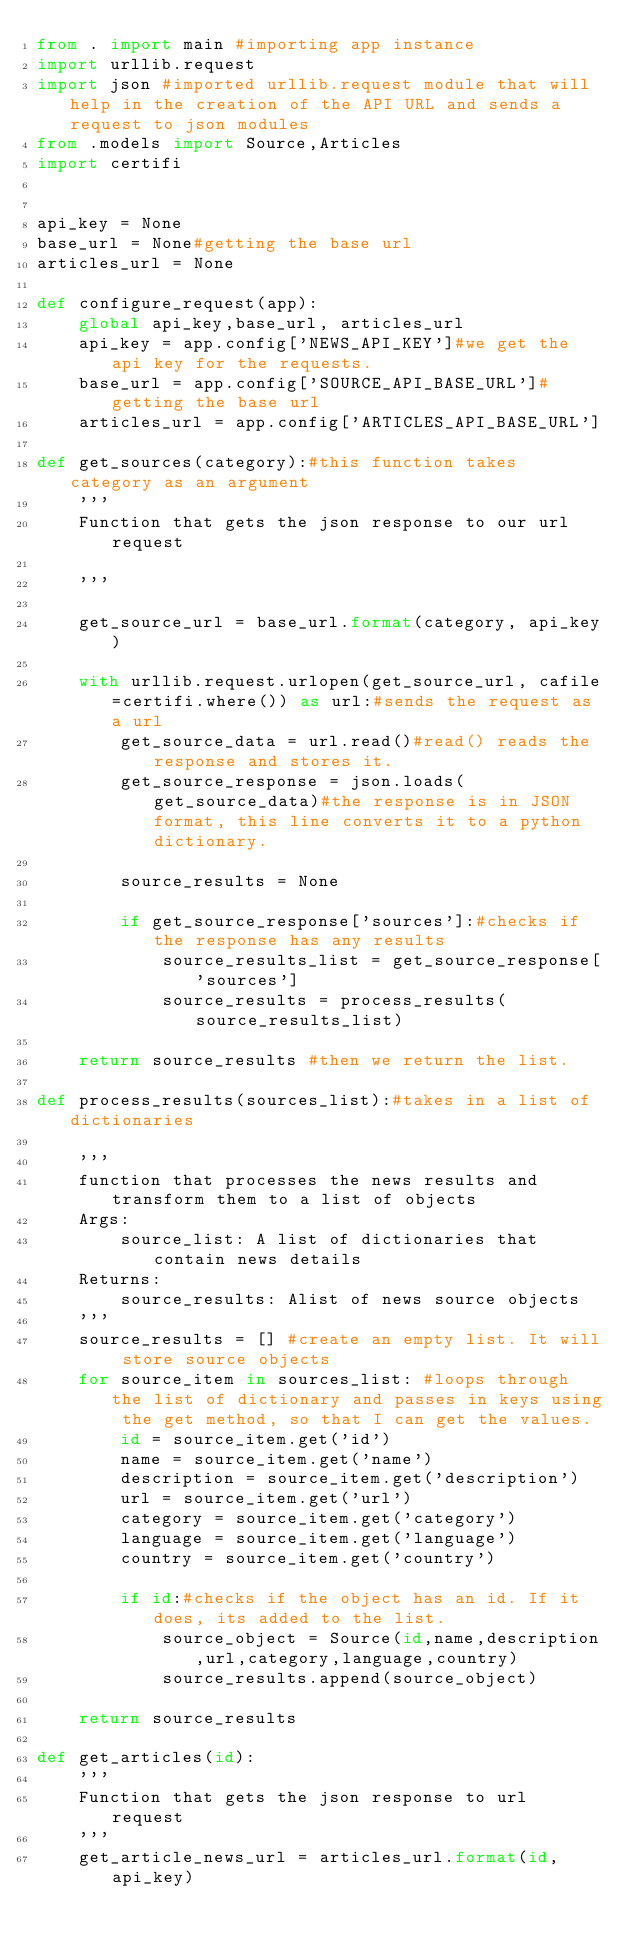<code> <loc_0><loc_0><loc_500><loc_500><_Python_>from . import main #importing app instance
import urllib.request 
import json #imported urllib.request module that will help in the creation of the API URL and sends a request to json modules
from .models import Source,Articles
import certifi


api_key = None
base_url = None#getting the base url 
articles_url = None

def configure_request(app):
    global api_key,base_url, articles_url
    api_key = app.config['NEWS_API_KEY']#we get the api key for the requests.
    base_url = app.config['SOURCE_API_BASE_URL']#getting the base url 
    articles_url = app.config['ARTICLES_API_BASE_URL']

def get_sources(category):#this function takes category as an argument
    '''
    Function that gets the json response to our url request

    '''

    get_source_url = base_url.format(category, api_key)

    with urllib.request.urlopen(get_source_url, cafile=certifi.where()) as url:#sends the request as a url
        get_source_data = url.read()#read() reads the response and stores it.
        get_source_response = json.loads(get_source_data)#the response is in JSON format, this line converts it to a python dictionary.

        source_results = None

        if get_source_response['sources']:#checks if the response has any results
            source_results_list = get_source_response['sources']
            source_results = process_results(source_results_list)

    return source_results #then we return the list.

def process_results(sources_list):#takes in a list of dictionaries
    
    '''
    function that processes the news results and transform them to a list of objects
    Args:
        source_list: A list of dictionaries that contain news details
    Returns:
        source_results: Alist of news source objects
    '''
    source_results = [] #create an empty list. It will store source objects
    for source_item in sources_list: #loops through the list of dictionary and passes in keys using the get method, so that I can get the values.
        id = source_item.get('id')
        name = source_item.get('name')
        description = source_item.get('description')
        url = source_item.get('url')
        category = source_item.get('category')
        language = source_item.get('language')
        country = source_item.get('country')

        if id:#checks if the object has an id. If it does, its added to the list.
            source_object = Source(id,name,description,url,category,language,country)
            source_results.append(source_object)

    return source_results

def get_articles(id):
    '''
    Function that gets the json response to url request
    '''
    get_article_news_url = articles_url.format(id,api_key)</code> 